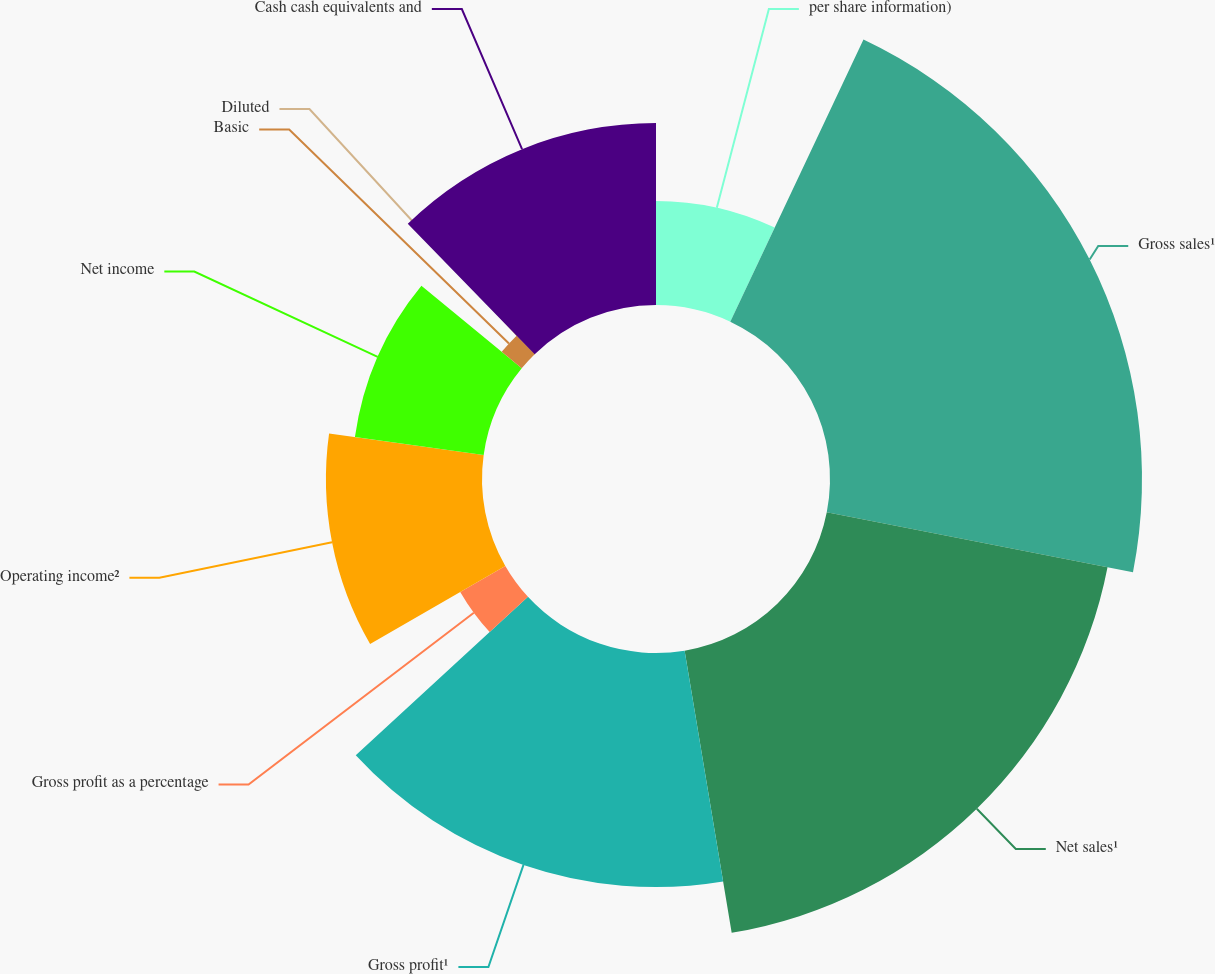Convert chart. <chart><loc_0><loc_0><loc_500><loc_500><pie_chart><fcel>per share information)<fcel>Gross sales¹<fcel>Net sales¹<fcel>Gross profit¹<fcel>Gross profit as a percentage<fcel>Operating income²<fcel>Net income<fcel>Basic<fcel>Diluted<fcel>Cash cash equivalents and<nl><fcel>7.02%<fcel>21.05%<fcel>19.3%<fcel>15.79%<fcel>3.51%<fcel>10.53%<fcel>8.77%<fcel>1.75%<fcel>0.0%<fcel>12.28%<nl></chart> 